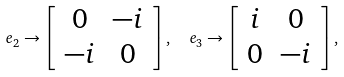<formula> <loc_0><loc_0><loc_500><loc_500>e _ { 2 } \rightarrow \left [ \begin{array} { c c } 0 & - i \\ - i & 0 \end{array} \right ] , \ \ e _ { 3 } \rightarrow \left [ \begin{array} { c c } i & 0 \\ 0 & - i \end{array} \right ] ,</formula> 